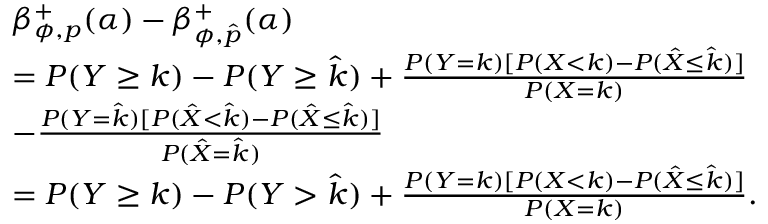Convert formula to latex. <formula><loc_0><loc_0><loc_500><loc_500>\begin{array} { r l } & { \beta _ { \phi , p } ^ { + } ( \alpha ) - \beta _ { \phi , \hat { p } } ^ { + } ( \alpha ) } \\ & { = P ( Y \geq k ) - P ( Y \geq \hat { k } ) + \frac { P ( Y = k ) [ P ( X < k ) - P ( \hat { X } \leq \hat { k } ) ] } { P ( X = k ) } } \\ & { - \frac { P ( Y = \hat { k } ) [ P ( \hat { X } < \hat { k } ) - P ( \hat { X } \leq \hat { k } ) ] } { P ( \hat { X } = \hat { k } ) } } \\ & { = P ( Y \geq k ) - P ( Y > \hat { k } ) + \frac { P ( Y = k ) [ P ( X < k ) - P ( \hat { X } \leq \hat { k } ) ] } { P ( X = k ) } . } \end{array}</formula> 